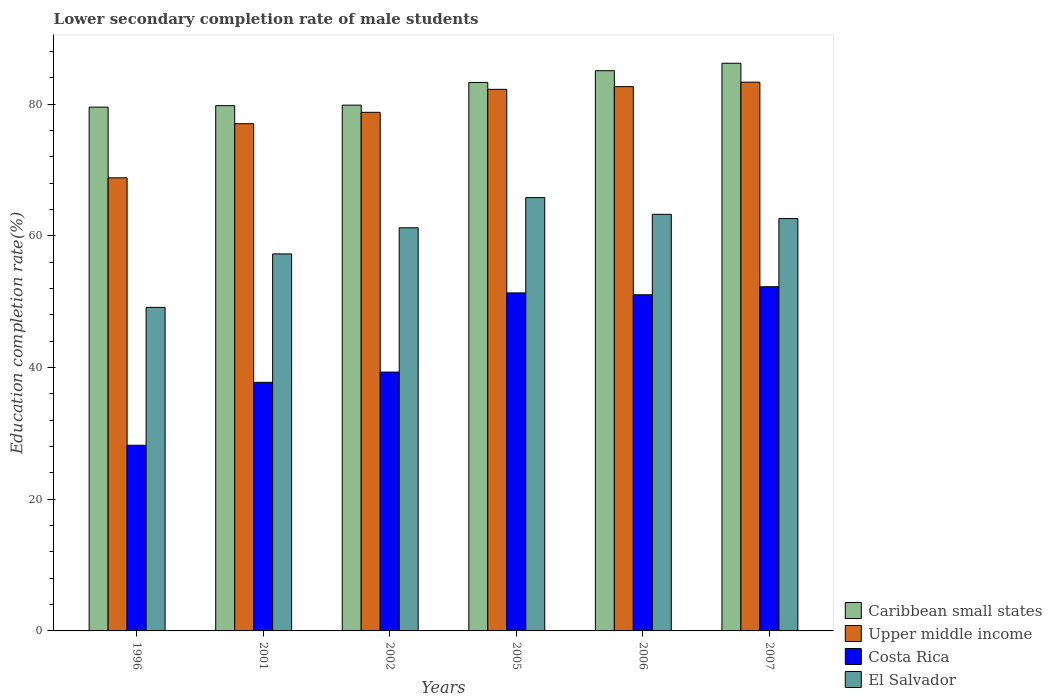How many different coloured bars are there?
Ensure brevity in your answer.  4. What is the label of the 3rd group of bars from the left?
Make the answer very short. 2002. In how many cases, is the number of bars for a given year not equal to the number of legend labels?
Make the answer very short. 0. What is the lower secondary completion rate of male students in Caribbean small states in 2006?
Provide a succinct answer. 85.1. Across all years, what is the maximum lower secondary completion rate of male students in Caribbean small states?
Make the answer very short. 86.23. Across all years, what is the minimum lower secondary completion rate of male students in Costa Rica?
Your answer should be very brief. 28.2. What is the total lower secondary completion rate of male students in Costa Rica in the graph?
Make the answer very short. 259.99. What is the difference between the lower secondary completion rate of male students in Upper middle income in 2005 and that in 2006?
Provide a succinct answer. -0.41. What is the difference between the lower secondary completion rate of male students in Upper middle income in 2005 and the lower secondary completion rate of male students in Costa Rica in 2006?
Your response must be concise. 31.2. What is the average lower secondary completion rate of male students in El Salvador per year?
Keep it short and to the point. 59.9. In the year 1996, what is the difference between the lower secondary completion rate of male students in Costa Rica and lower secondary completion rate of male students in Upper middle income?
Keep it short and to the point. -40.63. In how many years, is the lower secondary completion rate of male students in Costa Rica greater than 40 %?
Keep it short and to the point. 3. What is the ratio of the lower secondary completion rate of male students in Caribbean small states in 2001 to that in 2007?
Your answer should be very brief. 0.93. What is the difference between the highest and the second highest lower secondary completion rate of male students in Caribbean small states?
Provide a succinct answer. 1.13. What is the difference between the highest and the lowest lower secondary completion rate of male students in Upper middle income?
Provide a succinct answer. 14.53. Is the sum of the lower secondary completion rate of male students in Caribbean small states in 2002 and 2005 greater than the maximum lower secondary completion rate of male students in Upper middle income across all years?
Give a very brief answer. Yes. What does the 1st bar from the left in 2002 represents?
Provide a succinct answer. Caribbean small states. What does the 3rd bar from the right in 2007 represents?
Provide a short and direct response. Upper middle income. Is it the case that in every year, the sum of the lower secondary completion rate of male students in Upper middle income and lower secondary completion rate of male students in Costa Rica is greater than the lower secondary completion rate of male students in Caribbean small states?
Offer a terse response. Yes. Are all the bars in the graph horizontal?
Your response must be concise. No. What is the difference between two consecutive major ticks on the Y-axis?
Offer a terse response. 20. Are the values on the major ticks of Y-axis written in scientific E-notation?
Offer a very short reply. No. Does the graph contain any zero values?
Offer a terse response. No. Does the graph contain grids?
Your answer should be compact. No. Where does the legend appear in the graph?
Provide a succinct answer. Bottom right. What is the title of the graph?
Provide a succinct answer. Lower secondary completion rate of male students. Does "Chad" appear as one of the legend labels in the graph?
Provide a short and direct response. No. What is the label or title of the X-axis?
Give a very brief answer. Years. What is the label or title of the Y-axis?
Your answer should be very brief. Education completion rate(%). What is the Education completion rate(%) in Caribbean small states in 1996?
Keep it short and to the point. 79.57. What is the Education completion rate(%) of Upper middle income in 1996?
Your answer should be very brief. 68.83. What is the Education completion rate(%) in Costa Rica in 1996?
Your answer should be very brief. 28.2. What is the Education completion rate(%) in El Salvador in 1996?
Offer a very short reply. 49.15. What is the Education completion rate(%) of Caribbean small states in 2001?
Your response must be concise. 79.79. What is the Education completion rate(%) of Upper middle income in 2001?
Make the answer very short. 77.05. What is the Education completion rate(%) in Costa Rica in 2001?
Provide a short and direct response. 37.76. What is the Education completion rate(%) in El Salvador in 2001?
Your answer should be compact. 57.27. What is the Education completion rate(%) in Caribbean small states in 2002?
Offer a very short reply. 79.87. What is the Education completion rate(%) of Upper middle income in 2002?
Your response must be concise. 78.78. What is the Education completion rate(%) of Costa Rica in 2002?
Offer a very short reply. 39.32. What is the Education completion rate(%) of El Salvador in 2002?
Make the answer very short. 61.24. What is the Education completion rate(%) of Caribbean small states in 2005?
Give a very brief answer. 83.32. What is the Education completion rate(%) in Upper middle income in 2005?
Offer a terse response. 82.27. What is the Education completion rate(%) of Costa Rica in 2005?
Offer a terse response. 51.35. What is the Education completion rate(%) in El Salvador in 2005?
Give a very brief answer. 65.83. What is the Education completion rate(%) of Caribbean small states in 2006?
Your answer should be very brief. 85.1. What is the Education completion rate(%) in Upper middle income in 2006?
Make the answer very short. 82.68. What is the Education completion rate(%) in Costa Rica in 2006?
Your answer should be compact. 51.07. What is the Education completion rate(%) in El Salvador in 2006?
Ensure brevity in your answer.  63.29. What is the Education completion rate(%) of Caribbean small states in 2007?
Offer a very short reply. 86.23. What is the Education completion rate(%) in Upper middle income in 2007?
Your answer should be compact. 83.36. What is the Education completion rate(%) in Costa Rica in 2007?
Keep it short and to the point. 52.29. What is the Education completion rate(%) of El Salvador in 2007?
Provide a short and direct response. 62.64. Across all years, what is the maximum Education completion rate(%) in Caribbean small states?
Provide a short and direct response. 86.23. Across all years, what is the maximum Education completion rate(%) in Upper middle income?
Ensure brevity in your answer.  83.36. Across all years, what is the maximum Education completion rate(%) of Costa Rica?
Your answer should be very brief. 52.29. Across all years, what is the maximum Education completion rate(%) in El Salvador?
Ensure brevity in your answer.  65.83. Across all years, what is the minimum Education completion rate(%) of Caribbean small states?
Your response must be concise. 79.57. Across all years, what is the minimum Education completion rate(%) of Upper middle income?
Your response must be concise. 68.83. Across all years, what is the minimum Education completion rate(%) in Costa Rica?
Your response must be concise. 28.2. Across all years, what is the minimum Education completion rate(%) of El Salvador?
Make the answer very short. 49.15. What is the total Education completion rate(%) of Caribbean small states in the graph?
Provide a short and direct response. 493.88. What is the total Education completion rate(%) in Upper middle income in the graph?
Provide a short and direct response. 472.97. What is the total Education completion rate(%) in Costa Rica in the graph?
Your answer should be very brief. 259.99. What is the total Education completion rate(%) in El Salvador in the graph?
Your answer should be compact. 359.41. What is the difference between the Education completion rate(%) of Caribbean small states in 1996 and that in 2001?
Provide a succinct answer. -0.22. What is the difference between the Education completion rate(%) of Upper middle income in 1996 and that in 2001?
Make the answer very short. -8.22. What is the difference between the Education completion rate(%) in Costa Rica in 1996 and that in 2001?
Offer a terse response. -9.56. What is the difference between the Education completion rate(%) of El Salvador in 1996 and that in 2001?
Give a very brief answer. -8.12. What is the difference between the Education completion rate(%) of Caribbean small states in 1996 and that in 2002?
Make the answer very short. -0.3. What is the difference between the Education completion rate(%) in Upper middle income in 1996 and that in 2002?
Provide a succinct answer. -9.95. What is the difference between the Education completion rate(%) of Costa Rica in 1996 and that in 2002?
Your answer should be compact. -11.12. What is the difference between the Education completion rate(%) of El Salvador in 1996 and that in 2002?
Keep it short and to the point. -12.09. What is the difference between the Education completion rate(%) in Caribbean small states in 1996 and that in 2005?
Your answer should be very brief. -3.75. What is the difference between the Education completion rate(%) of Upper middle income in 1996 and that in 2005?
Offer a terse response. -13.44. What is the difference between the Education completion rate(%) in Costa Rica in 1996 and that in 2005?
Offer a very short reply. -23.14. What is the difference between the Education completion rate(%) in El Salvador in 1996 and that in 2005?
Offer a very short reply. -16.68. What is the difference between the Education completion rate(%) in Caribbean small states in 1996 and that in 2006?
Give a very brief answer. -5.53. What is the difference between the Education completion rate(%) in Upper middle income in 1996 and that in 2006?
Your answer should be compact. -13.85. What is the difference between the Education completion rate(%) of Costa Rica in 1996 and that in 2006?
Offer a very short reply. -22.86. What is the difference between the Education completion rate(%) in El Salvador in 1996 and that in 2006?
Your answer should be very brief. -14.14. What is the difference between the Education completion rate(%) in Caribbean small states in 1996 and that in 2007?
Your answer should be compact. -6.66. What is the difference between the Education completion rate(%) in Upper middle income in 1996 and that in 2007?
Your answer should be very brief. -14.53. What is the difference between the Education completion rate(%) of Costa Rica in 1996 and that in 2007?
Offer a terse response. -24.08. What is the difference between the Education completion rate(%) in El Salvador in 1996 and that in 2007?
Ensure brevity in your answer.  -13.49. What is the difference between the Education completion rate(%) of Caribbean small states in 2001 and that in 2002?
Offer a very short reply. -0.08. What is the difference between the Education completion rate(%) of Upper middle income in 2001 and that in 2002?
Your answer should be very brief. -1.73. What is the difference between the Education completion rate(%) in Costa Rica in 2001 and that in 2002?
Make the answer very short. -1.56. What is the difference between the Education completion rate(%) in El Salvador in 2001 and that in 2002?
Your answer should be very brief. -3.97. What is the difference between the Education completion rate(%) in Caribbean small states in 2001 and that in 2005?
Give a very brief answer. -3.52. What is the difference between the Education completion rate(%) of Upper middle income in 2001 and that in 2005?
Keep it short and to the point. -5.22. What is the difference between the Education completion rate(%) in Costa Rica in 2001 and that in 2005?
Ensure brevity in your answer.  -13.59. What is the difference between the Education completion rate(%) of El Salvador in 2001 and that in 2005?
Your answer should be compact. -8.56. What is the difference between the Education completion rate(%) of Caribbean small states in 2001 and that in 2006?
Keep it short and to the point. -5.31. What is the difference between the Education completion rate(%) of Upper middle income in 2001 and that in 2006?
Your response must be concise. -5.63. What is the difference between the Education completion rate(%) of Costa Rica in 2001 and that in 2006?
Offer a terse response. -13.3. What is the difference between the Education completion rate(%) of El Salvador in 2001 and that in 2006?
Make the answer very short. -6.02. What is the difference between the Education completion rate(%) in Caribbean small states in 2001 and that in 2007?
Offer a very short reply. -6.44. What is the difference between the Education completion rate(%) of Upper middle income in 2001 and that in 2007?
Offer a very short reply. -6.31. What is the difference between the Education completion rate(%) in Costa Rica in 2001 and that in 2007?
Provide a short and direct response. -14.53. What is the difference between the Education completion rate(%) in El Salvador in 2001 and that in 2007?
Your response must be concise. -5.37. What is the difference between the Education completion rate(%) of Caribbean small states in 2002 and that in 2005?
Your answer should be compact. -3.44. What is the difference between the Education completion rate(%) of Upper middle income in 2002 and that in 2005?
Provide a succinct answer. -3.49. What is the difference between the Education completion rate(%) in Costa Rica in 2002 and that in 2005?
Your response must be concise. -12.03. What is the difference between the Education completion rate(%) of El Salvador in 2002 and that in 2005?
Ensure brevity in your answer.  -4.59. What is the difference between the Education completion rate(%) in Caribbean small states in 2002 and that in 2006?
Offer a very short reply. -5.23. What is the difference between the Education completion rate(%) in Upper middle income in 2002 and that in 2006?
Provide a short and direct response. -3.9. What is the difference between the Education completion rate(%) of Costa Rica in 2002 and that in 2006?
Your answer should be very brief. -11.75. What is the difference between the Education completion rate(%) in El Salvador in 2002 and that in 2006?
Offer a very short reply. -2.05. What is the difference between the Education completion rate(%) in Caribbean small states in 2002 and that in 2007?
Keep it short and to the point. -6.36. What is the difference between the Education completion rate(%) of Upper middle income in 2002 and that in 2007?
Give a very brief answer. -4.58. What is the difference between the Education completion rate(%) in Costa Rica in 2002 and that in 2007?
Offer a very short reply. -12.97. What is the difference between the Education completion rate(%) in El Salvador in 2002 and that in 2007?
Your answer should be compact. -1.4. What is the difference between the Education completion rate(%) in Caribbean small states in 2005 and that in 2006?
Your answer should be very brief. -1.79. What is the difference between the Education completion rate(%) in Upper middle income in 2005 and that in 2006?
Provide a short and direct response. -0.41. What is the difference between the Education completion rate(%) of Costa Rica in 2005 and that in 2006?
Give a very brief answer. 0.28. What is the difference between the Education completion rate(%) of El Salvador in 2005 and that in 2006?
Provide a succinct answer. 2.54. What is the difference between the Education completion rate(%) in Caribbean small states in 2005 and that in 2007?
Your answer should be very brief. -2.92. What is the difference between the Education completion rate(%) in Upper middle income in 2005 and that in 2007?
Make the answer very short. -1.09. What is the difference between the Education completion rate(%) in Costa Rica in 2005 and that in 2007?
Provide a succinct answer. -0.94. What is the difference between the Education completion rate(%) in El Salvador in 2005 and that in 2007?
Offer a very short reply. 3.19. What is the difference between the Education completion rate(%) of Caribbean small states in 2006 and that in 2007?
Make the answer very short. -1.13. What is the difference between the Education completion rate(%) of Upper middle income in 2006 and that in 2007?
Provide a succinct answer. -0.68. What is the difference between the Education completion rate(%) of Costa Rica in 2006 and that in 2007?
Your answer should be compact. -1.22. What is the difference between the Education completion rate(%) of El Salvador in 2006 and that in 2007?
Your answer should be compact. 0.65. What is the difference between the Education completion rate(%) of Caribbean small states in 1996 and the Education completion rate(%) of Upper middle income in 2001?
Keep it short and to the point. 2.52. What is the difference between the Education completion rate(%) of Caribbean small states in 1996 and the Education completion rate(%) of Costa Rica in 2001?
Ensure brevity in your answer.  41.81. What is the difference between the Education completion rate(%) of Caribbean small states in 1996 and the Education completion rate(%) of El Salvador in 2001?
Offer a very short reply. 22.3. What is the difference between the Education completion rate(%) of Upper middle income in 1996 and the Education completion rate(%) of Costa Rica in 2001?
Your response must be concise. 31.07. What is the difference between the Education completion rate(%) in Upper middle income in 1996 and the Education completion rate(%) in El Salvador in 2001?
Ensure brevity in your answer.  11.56. What is the difference between the Education completion rate(%) of Costa Rica in 1996 and the Education completion rate(%) of El Salvador in 2001?
Make the answer very short. -29.07. What is the difference between the Education completion rate(%) of Caribbean small states in 1996 and the Education completion rate(%) of Upper middle income in 2002?
Offer a terse response. 0.79. What is the difference between the Education completion rate(%) in Caribbean small states in 1996 and the Education completion rate(%) in Costa Rica in 2002?
Ensure brevity in your answer.  40.25. What is the difference between the Education completion rate(%) in Caribbean small states in 1996 and the Education completion rate(%) in El Salvador in 2002?
Offer a very short reply. 18.33. What is the difference between the Education completion rate(%) of Upper middle income in 1996 and the Education completion rate(%) of Costa Rica in 2002?
Make the answer very short. 29.51. What is the difference between the Education completion rate(%) of Upper middle income in 1996 and the Education completion rate(%) of El Salvador in 2002?
Make the answer very short. 7.59. What is the difference between the Education completion rate(%) in Costa Rica in 1996 and the Education completion rate(%) in El Salvador in 2002?
Offer a terse response. -33.04. What is the difference between the Education completion rate(%) in Caribbean small states in 1996 and the Education completion rate(%) in Upper middle income in 2005?
Keep it short and to the point. -2.7. What is the difference between the Education completion rate(%) in Caribbean small states in 1996 and the Education completion rate(%) in Costa Rica in 2005?
Your response must be concise. 28.22. What is the difference between the Education completion rate(%) of Caribbean small states in 1996 and the Education completion rate(%) of El Salvador in 2005?
Give a very brief answer. 13.74. What is the difference between the Education completion rate(%) of Upper middle income in 1996 and the Education completion rate(%) of Costa Rica in 2005?
Your answer should be compact. 17.48. What is the difference between the Education completion rate(%) in Upper middle income in 1996 and the Education completion rate(%) in El Salvador in 2005?
Your response must be concise. 3. What is the difference between the Education completion rate(%) of Costa Rica in 1996 and the Education completion rate(%) of El Salvador in 2005?
Keep it short and to the point. -37.63. What is the difference between the Education completion rate(%) in Caribbean small states in 1996 and the Education completion rate(%) in Upper middle income in 2006?
Your response must be concise. -3.11. What is the difference between the Education completion rate(%) of Caribbean small states in 1996 and the Education completion rate(%) of Costa Rica in 2006?
Your answer should be compact. 28.5. What is the difference between the Education completion rate(%) of Caribbean small states in 1996 and the Education completion rate(%) of El Salvador in 2006?
Your answer should be very brief. 16.28. What is the difference between the Education completion rate(%) of Upper middle income in 1996 and the Education completion rate(%) of Costa Rica in 2006?
Provide a short and direct response. 17.76. What is the difference between the Education completion rate(%) of Upper middle income in 1996 and the Education completion rate(%) of El Salvador in 2006?
Give a very brief answer. 5.54. What is the difference between the Education completion rate(%) of Costa Rica in 1996 and the Education completion rate(%) of El Salvador in 2006?
Your answer should be compact. -35.08. What is the difference between the Education completion rate(%) of Caribbean small states in 1996 and the Education completion rate(%) of Upper middle income in 2007?
Offer a terse response. -3.79. What is the difference between the Education completion rate(%) of Caribbean small states in 1996 and the Education completion rate(%) of Costa Rica in 2007?
Offer a very short reply. 27.28. What is the difference between the Education completion rate(%) in Caribbean small states in 1996 and the Education completion rate(%) in El Salvador in 2007?
Give a very brief answer. 16.93. What is the difference between the Education completion rate(%) of Upper middle income in 1996 and the Education completion rate(%) of Costa Rica in 2007?
Your response must be concise. 16.54. What is the difference between the Education completion rate(%) of Upper middle income in 1996 and the Education completion rate(%) of El Salvador in 2007?
Provide a short and direct response. 6.19. What is the difference between the Education completion rate(%) in Costa Rica in 1996 and the Education completion rate(%) in El Salvador in 2007?
Provide a short and direct response. -34.44. What is the difference between the Education completion rate(%) of Caribbean small states in 2001 and the Education completion rate(%) of Upper middle income in 2002?
Your answer should be compact. 1.01. What is the difference between the Education completion rate(%) of Caribbean small states in 2001 and the Education completion rate(%) of Costa Rica in 2002?
Ensure brevity in your answer.  40.47. What is the difference between the Education completion rate(%) of Caribbean small states in 2001 and the Education completion rate(%) of El Salvador in 2002?
Make the answer very short. 18.55. What is the difference between the Education completion rate(%) in Upper middle income in 2001 and the Education completion rate(%) in Costa Rica in 2002?
Your answer should be compact. 37.73. What is the difference between the Education completion rate(%) of Upper middle income in 2001 and the Education completion rate(%) of El Salvador in 2002?
Make the answer very short. 15.81. What is the difference between the Education completion rate(%) of Costa Rica in 2001 and the Education completion rate(%) of El Salvador in 2002?
Your answer should be compact. -23.48. What is the difference between the Education completion rate(%) in Caribbean small states in 2001 and the Education completion rate(%) in Upper middle income in 2005?
Keep it short and to the point. -2.48. What is the difference between the Education completion rate(%) in Caribbean small states in 2001 and the Education completion rate(%) in Costa Rica in 2005?
Give a very brief answer. 28.45. What is the difference between the Education completion rate(%) of Caribbean small states in 2001 and the Education completion rate(%) of El Salvador in 2005?
Provide a succinct answer. 13.97. What is the difference between the Education completion rate(%) in Upper middle income in 2001 and the Education completion rate(%) in Costa Rica in 2005?
Keep it short and to the point. 25.7. What is the difference between the Education completion rate(%) of Upper middle income in 2001 and the Education completion rate(%) of El Salvador in 2005?
Your answer should be very brief. 11.22. What is the difference between the Education completion rate(%) in Costa Rica in 2001 and the Education completion rate(%) in El Salvador in 2005?
Your answer should be compact. -28.07. What is the difference between the Education completion rate(%) of Caribbean small states in 2001 and the Education completion rate(%) of Upper middle income in 2006?
Make the answer very short. -2.89. What is the difference between the Education completion rate(%) in Caribbean small states in 2001 and the Education completion rate(%) in Costa Rica in 2006?
Provide a succinct answer. 28.73. What is the difference between the Education completion rate(%) of Caribbean small states in 2001 and the Education completion rate(%) of El Salvador in 2006?
Make the answer very short. 16.51. What is the difference between the Education completion rate(%) in Upper middle income in 2001 and the Education completion rate(%) in Costa Rica in 2006?
Offer a terse response. 25.98. What is the difference between the Education completion rate(%) in Upper middle income in 2001 and the Education completion rate(%) in El Salvador in 2006?
Make the answer very short. 13.77. What is the difference between the Education completion rate(%) in Costa Rica in 2001 and the Education completion rate(%) in El Salvador in 2006?
Provide a succinct answer. -25.52. What is the difference between the Education completion rate(%) of Caribbean small states in 2001 and the Education completion rate(%) of Upper middle income in 2007?
Offer a terse response. -3.56. What is the difference between the Education completion rate(%) of Caribbean small states in 2001 and the Education completion rate(%) of Costa Rica in 2007?
Your response must be concise. 27.51. What is the difference between the Education completion rate(%) in Caribbean small states in 2001 and the Education completion rate(%) in El Salvador in 2007?
Offer a terse response. 17.15. What is the difference between the Education completion rate(%) in Upper middle income in 2001 and the Education completion rate(%) in Costa Rica in 2007?
Your response must be concise. 24.76. What is the difference between the Education completion rate(%) in Upper middle income in 2001 and the Education completion rate(%) in El Salvador in 2007?
Provide a succinct answer. 14.41. What is the difference between the Education completion rate(%) of Costa Rica in 2001 and the Education completion rate(%) of El Salvador in 2007?
Keep it short and to the point. -24.88. What is the difference between the Education completion rate(%) in Caribbean small states in 2002 and the Education completion rate(%) in Upper middle income in 2005?
Offer a very short reply. -2.4. What is the difference between the Education completion rate(%) in Caribbean small states in 2002 and the Education completion rate(%) in Costa Rica in 2005?
Offer a terse response. 28.52. What is the difference between the Education completion rate(%) in Caribbean small states in 2002 and the Education completion rate(%) in El Salvador in 2005?
Your answer should be very brief. 14.04. What is the difference between the Education completion rate(%) in Upper middle income in 2002 and the Education completion rate(%) in Costa Rica in 2005?
Keep it short and to the point. 27.43. What is the difference between the Education completion rate(%) of Upper middle income in 2002 and the Education completion rate(%) of El Salvador in 2005?
Offer a very short reply. 12.95. What is the difference between the Education completion rate(%) in Costa Rica in 2002 and the Education completion rate(%) in El Salvador in 2005?
Your answer should be very brief. -26.51. What is the difference between the Education completion rate(%) in Caribbean small states in 2002 and the Education completion rate(%) in Upper middle income in 2006?
Your answer should be compact. -2.81. What is the difference between the Education completion rate(%) of Caribbean small states in 2002 and the Education completion rate(%) of Costa Rica in 2006?
Offer a very short reply. 28.81. What is the difference between the Education completion rate(%) in Caribbean small states in 2002 and the Education completion rate(%) in El Salvador in 2006?
Your answer should be compact. 16.59. What is the difference between the Education completion rate(%) in Upper middle income in 2002 and the Education completion rate(%) in Costa Rica in 2006?
Your answer should be very brief. 27.71. What is the difference between the Education completion rate(%) of Upper middle income in 2002 and the Education completion rate(%) of El Salvador in 2006?
Provide a succinct answer. 15.5. What is the difference between the Education completion rate(%) in Costa Rica in 2002 and the Education completion rate(%) in El Salvador in 2006?
Ensure brevity in your answer.  -23.97. What is the difference between the Education completion rate(%) of Caribbean small states in 2002 and the Education completion rate(%) of Upper middle income in 2007?
Offer a terse response. -3.49. What is the difference between the Education completion rate(%) of Caribbean small states in 2002 and the Education completion rate(%) of Costa Rica in 2007?
Your answer should be compact. 27.58. What is the difference between the Education completion rate(%) in Caribbean small states in 2002 and the Education completion rate(%) in El Salvador in 2007?
Make the answer very short. 17.23. What is the difference between the Education completion rate(%) in Upper middle income in 2002 and the Education completion rate(%) in Costa Rica in 2007?
Give a very brief answer. 26.49. What is the difference between the Education completion rate(%) of Upper middle income in 2002 and the Education completion rate(%) of El Salvador in 2007?
Make the answer very short. 16.14. What is the difference between the Education completion rate(%) in Costa Rica in 2002 and the Education completion rate(%) in El Salvador in 2007?
Make the answer very short. -23.32. What is the difference between the Education completion rate(%) in Caribbean small states in 2005 and the Education completion rate(%) in Upper middle income in 2006?
Provide a succinct answer. 0.63. What is the difference between the Education completion rate(%) in Caribbean small states in 2005 and the Education completion rate(%) in Costa Rica in 2006?
Your response must be concise. 32.25. What is the difference between the Education completion rate(%) of Caribbean small states in 2005 and the Education completion rate(%) of El Salvador in 2006?
Provide a short and direct response. 20.03. What is the difference between the Education completion rate(%) in Upper middle income in 2005 and the Education completion rate(%) in Costa Rica in 2006?
Provide a short and direct response. 31.2. What is the difference between the Education completion rate(%) in Upper middle income in 2005 and the Education completion rate(%) in El Salvador in 2006?
Make the answer very short. 18.99. What is the difference between the Education completion rate(%) of Costa Rica in 2005 and the Education completion rate(%) of El Salvador in 2006?
Give a very brief answer. -11.94. What is the difference between the Education completion rate(%) of Caribbean small states in 2005 and the Education completion rate(%) of Upper middle income in 2007?
Ensure brevity in your answer.  -0.04. What is the difference between the Education completion rate(%) of Caribbean small states in 2005 and the Education completion rate(%) of Costa Rica in 2007?
Ensure brevity in your answer.  31.03. What is the difference between the Education completion rate(%) of Caribbean small states in 2005 and the Education completion rate(%) of El Salvador in 2007?
Provide a succinct answer. 20.68. What is the difference between the Education completion rate(%) of Upper middle income in 2005 and the Education completion rate(%) of Costa Rica in 2007?
Keep it short and to the point. 29.98. What is the difference between the Education completion rate(%) in Upper middle income in 2005 and the Education completion rate(%) in El Salvador in 2007?
Your response must be concise. 19.63. What is the difference between the Education completion rate(%) of Costa Rica in 2005 and the Education completion rate(%) of El Salvador in 2007?
Give a very brief answer. -11.29. What is the difference between the Education completion rate(%) of Caribbean small states in 2006 and the Education completion rate(%) of Upper middle income in 2007?
Provide a succinct answer. 1.74. What is the difference between the Education completion rate(%) in Caribbean small states in 2006 and the Education completion rate(%) in Costa Rica in 2007?
Your answer should be very brief. 32.81. What is the difference between the Education completion rate(%) in Caribbean small states in 2006 and the Education completion rate(%) in El Salvador in 2007?
Make the answer very short. 22.46. What is the difference between the Education completion rate(%) in Upper middle income in 2006 and the Education completion rate(%) in Costa Rica in 2007?
Make the answer very short. 30.39. What is the difference between the Education completion rate(%) of Upper middle income in 2006 and the Education completion rate(%) of El Salvador in 2007?
Keep it short and to the point. 20.04. What is the difference between the Education completion rate(%) of Costa Rica in 2006 and the Education completion rate(%) of El Salvador in 2007?
Offer a terse response. -11.57. What is the average Education completion rate(%) of Caribbean small states per year?
Offer a terse response. 82.31. What is the average Education completion rate(%) in Upper middle income per year?
Keep it short and to the point. 78.83. What is the average Education completion rate(%) in Costa Rica per year?
Provide a short and direct response. 43.33. What is the average Education completion rate(%) of El Salvador per year?
Your answer should be very brief. 59.9. In the year 1996, what is the difference between the Education completion rate(%) of Caribbean small states and Education completion rate(%) of Upper middle income?
Ensure brevity in your answer.  10.74. In the year 1996, what is the difference between the Education completion rate(%) of Caribbean small states and Education completion rate(%) of Costa Rica?
Keep it short and to the point. 51.37. In the year 1996, what is the difference between the Education completion rate(%) of Caribbean small states and Education completion rate(%) of El Salvador?
Give a very brief answer. 30.42. In the year 1996, what is the difference between the Education completion rate(%) of Upper middle income and Education completion rate(%) of Costa Rica?
Ensure brevity in your answer.  40.62. In the year 1996, what is the difference between the Education completion rate(%) in Upper middle income and Education completion rate(%) in El Salvador?
Provide a succinct answer. 19.68. In the year 1996, what is the difference between the Education completion rate(%) of Costa Rica and Education completion rate(%) of El Salvador?
Make the answer very short. -20.95. In the year 2001, what is the difference between the Education completion rate(%) of Caribbean small states and Education completion rate(%) of Upper middle income?
Provide a succinct answer. 2.74. In the year 2001, what is the difference between the Education completion rate(%) of Caribbean small states and Education completion rate(%) of Costa Rica?
Your answer should be very brief. 42.03. In the year 2001, what is the difference between the Education completion rate(%) of Caribbean small states and Education completion rate(%) of El Salvador?
Give a very brief answer. 22.53. In the year 2001, what is the difference between the Education completion rate(%) in Upper middle income and Education completion rate(%) in Costa Rica?
Offer a very short reply. 39.29. In the year 2001, what is the difference between the Education completion rate(%) in Upper middle income and Education completion rate(%) in El Salvador?
Offer a very short reply. 19.78. In the year 2001, what is the difference between the Education completion rate(%) in Costa Rica and Education completion rate(%) in El Salvador?
Offer a very short reply. -19.51. In the year 2002, what is the difference between the Education completion rate(%) in Caribbean small states and Education completion rate(%) in Upper middle income?
Ensure brevity in your answer.  1.09. In the year 2002, what is the difference between the Education completion rate(%) in Caribbean small states and Education completion rate(%) in Costa Rica?
Your response must be concise. 40.55. In the year 2002, what is the difference between the Education completion rate(%) in Caribbean small states and Education completion rate(%) in El Salvador?
Give a very brief answer. 18.63. In the year 2002, what is the difference between the Education completion rate(%) in Upper middle income and Education completion rate(%) in Costa Rica?
Make the answer very short. 39.46. In the year 2002, what is the difference between the Education completion rate(%) of Upper middle income and Education completion rate(%) of El Salvador?
Offer a terse response. 17.54. In the year 2002, what is the difference between the Education completion rate(%) in Costa Rica and Education completion rate(%) in El Salvador?
Provide a short and direct response. -21.92. In the year 2005, what is the difference between the Education completion rate(%) of Caribbean small states and Education completion rate(%) of Upper middle income?
Provide a short and direct response. 1.04. In the year 2005, what is the difference between the Education completion rate(%) in Caribbean small states and Education completion rate(%) in Costa Rica?
Ensure brevity in your answer.  31.97. In the year 2005, what is the difference between the Education completion rate(%) of Caribbean small states and Education completion rate(%) of El Salvador?
Make the answer very short. 17.49. In the year 2005, what is the difference between the Education completion rate(%) of Upper middle income and Education completion rate(%) of Costa Rica?
Ensure brevity in your answer.  30.92. In the year 2005, what is the difference between the Education completion rate(%) in Upper middle income and Education completion rate(%) in El Salvador?
Ensure brevity in your answer.  16.44. In the year 2005, what is the difference between the Education completion rate(%) of Costa Rica and Education completion rate(%) of El Salvador?
Ensure brevity in your answer.  -14.48. In the year 2006, what is the difference between the Education completion rate(%) of Caribbean small states and Education completion rate(%) of Upper middle income?
Provide a short and direct response. 2.42. In the year 2006, what is the difference between the Education completion rate(%) in Caribbean small states and Education completion rate(%) in Costa Rica?
Provide a succinct answer. 34.03. In the year 2006, what is the difference between the Education completion rate(%) in Caribbean small states and Education completion rate(%) in El Salvador?
Give a very brief answer. 21.82. In the year 2006, what is the difference between the Education completion rate(%) of Upper middle income and Education completion rate(%) of Costa Rica?
Give a very brief answer. 31.62. In the year 2006, what is the difference between the Education completion rate(%) of Upper middle income and Education completion rate(%) of El Salvador?
Your response must be concise. 19.4. In the year 2006, what is the difference between the Education completion rate(%) of Costa Rica and Education completion rate(%) of El Salvador?
Provide a short and direct response. -12.22. In the year 2007, what is the difference between the Education completion rate(%) of Caribbean small states and Education completion rate(%) of Upper middle income?
Make the answer very short. 2.87. In the year 2007, what is the difference between the Education completion rate(%) in Caribbean small states and Education completion rate(%) in Costa Rica?
Provide a succinct answer. 33.95. In the year 2007, what is the difference between the Education completion rate(%) of Caribbean small states and Education completion rate(%) of El Salvador?
Provide a short and direct response. 23.59. In the year 2007, what is the difference between the Education completion rate(%) of Upper middle income and Education completion rate(%) of Costa Rica?
Provide a succinct answer. 31.07. In the year 2007, what is the difference between the Education completion rate(%) in Upper middle income and Education completion rate(%) in El Salvador?
Provide a short and direct response. 20.72. In the year 2007, what is the difference between the Education completion rate(%) in Costa Rica and Education completion rate(%) in El Salvador?
Keep it short and to the point. -10.35. What is the ratio of the Education completion rate(%) of Upper middle income in 1996 to that in 2001?
Ensure brevity in your answer.  0.89. What is the ratio of the Education completion rate(%) of Costa Rica in 1996 to that in 2001?
Offer a terse response. 0.75. What is the ratio of the Education completion rate(%) in El Salvador in 1996 to that in 2001?
Provide a short and direct response. 0.86. What is the ratio of the Education completion rate(%) of Upper middle income in 1996 to that in 2002?
Offer a very short reply. 0.87. What is the ratio of the Education completion rate(%) in Costa Rica in 1996 to that in 2002?
Ensure brevity in your answer.  0.72. What is the ratio of the Education completion rate(%) of El Salvador in 1996 to that in 2002?
Offer a terse response. 0.8. What is the ratio of the Education completion rate(%) in Caribbean small states in 1996 to that in 2005?
Make the answer very short. 0.95. What is the ratio of the Education completion rate(%) of Upper middle income in 1996 to that in 2005?
Ensure brevity in your answer.  0.84. What is the ratio of the Education completion rate(%) of Costa Rica in 1996 to that in 2005?
Offer a very short reply. 0.55. What is the ratio of the Education completion rate(%) in El Salvador in 1996 to that in 2005?
Your answer should be very brief. 0.75. What is the ratio of the Education completion rate(%) of Caribbean small states in 1996 to that in 2006?
Make the answer very short. 0.94. What is the ratio of the Education completion rate(%) in Upper middle income in 1996 to that in 2006?
Ensure brevity in your answer.  0.83. What is the ratio of the Education completion rate(%) in Costa Rica in 1996 to that in 2006?
Offer a terse response. 0.55. What is the ratio of the Education completion rate(%) of El Salvador in 1996 to that in 2006?
Your answer should be very brief. 0.78. What is the ratio of the Education completion rate(%) in Caribbean small states in 1996 to that in 2007?
Your answer should be compact. 0.92. What is the ratio of the Education completion rate(%) of Upper middle income in 1996 to that in 2007?
Your answer should be compact. 0.83. What is the ratio of the Education completion rate(%) of Costa Rica in 1996 to that in 2007?
Provide a short and direct response. 0.54. What is the ratio of the Education completion rate(%) of El Salvador in 1996 to that in 2007?
Keep it short and to the point. 0.78. What is the ratio of the Education completion rate(%) in Caribbean small states in 2001 to that in 2002?
Provide a short and direct response. 1. What is the ratio of the Education completion rate(%) in Upper middle income in 2001 to that in 2002?
Ensure brevity in your answer.  0.98. What is the ratio of the Education completion rate(%) of Costa Rica in 2001 to that in 2002?
Keep it short and to the point. 0.96. What is the ratio of the Education completion rate(%) of El Salvador in 2001 to that in 2002?
Make the answer very short. 0.94. What is the ratio of the Education completion rate(%) in Caribbean small states in 2001 to that in 2005?
Provide a short and direct response. 0.96. What is the ratio of the Education completion rate(%) of Upper middle income in 2001 to that in 2005?
Give a very brief answer. 0.94. What is the ratio of the Education completion rate(%) in Costa Rica in 2001 to that in 2005?
Make the answer very short. 0.74. What is the ratio of the Education completion rate(%) of El Salvador in 2001 to that in 2005?
Keep it short and to the point. 0.87. What is the ratio of the Education completion rate(%) of Caribbean small states in 2001 to that in 2006?
Your answer should be compact. 0.94. What is the ratio of the Education completion rate(%) of Upper middle income in 2001 to that in 2006?
Your answer should be compact. 0.93. What is the ratio of the Education completion rate(%) of Costa Rica in 2001 to that in 2006?
Offer a terse response. 0.74. What is the ratio of the Education completion rate(%) of El Salvador in 2001 to that in 2006?
Keep it short and to the point. 0.9. What is the ratio of the Education completion rate(%) of Caribbean small states in 2001 to that in 2007?
Your answer should be compact. 0.93. What is the ratio of the Education completion rate(%) in Upper middle income in 2001 to that in 2007?
Your answer should be very brief. 0.92. What is the ratio of the Education completion rate(%) of Costa Rica in 2001 to that in 2007?
Offer a terse response. 0.72. What is the ratio of the Education completion rate(%) in El Salvador in 2001 to that in 2007?
Offer a very short reply. 0.91. What is the ratio of the Education completion rate(%) in Caribbean small states in 2002 to that in 2005?
Your response must be concise. 0.96. What is the ratio of the Education completion rate(%) in Upper middle income in 2002 to that in 2005?
Your answer should be compact. 0.96. What is the ratio of the Education completion rate(%) in Costa Rica in 2002 to that in 2005?
Offer a very short reply. 0.77. What is the ratio of the Education completion rate(%) of El Salvador in 2002 to that in 2005?
Offer a terse response. 0.93. What is the ratio of the Education completion rate(%) in Caribbean small states in 2002 to that in 2006?
Your response must be concise. 0.94. What is the ratio of the Education completion rate(%) of Upper middle income in 2002 to that in 2006?
Your response must be concise. 0.95. What is the ratio of the Education completion rate(%) in Costa Rica in 2002 to that in 2006?
Your answer should be compact. 0.77. What is the ratio of the Education completion rate(%) in Caribbean small states in 2002 to that in 2007?
Provide a short and direct response. 0.93. What is the ratio of the Education completion rate(%) of Upper middle income in 2002 to that in 2007?
Provide a short and direct response. 0.95. What is the ratio of the Education completion rate(%) in Costa Rica in 2002 to that in 2007?
Make the answer very short. 0.75. What is the ratio of the Education completion rate(%) in El Salvador in 2002 to that in 2007?
Offer a very short reply. 0.98. What is the ratio of the Education completion rate(%) of Upper middle income in 2005 to that in 2006?
Give a very brief answer. 0.99. What is the ratio of the Education completion rate(%) of El Salvador in 2005 to that in 2006?
Give a very brief answer. 1.04. What is the ratio of the Education completion rate(%) in Caribbean small states in 2005 to that in 2007?
Provide a succinct answer. 0.97. What is the ratio of the Education completion rate(%) of Costa Rica in 2005 to that in 2007?
Ensure brevity in your answer.  0.98. What is the ratio of the Education completion rate(%) in El Salvador in 2005 to that in 2007?
Ensure brevity in your answer.  1.05. What is the ratio of the Education completion rate(%) of Caribbean small states in 2006 to that in 2007?
Provide a succinct answer. 0.99. What is the ratio of the Education completion rate(%) in Costa Rica in 2006 to that in 2007?
Give a very brief answer. 0.98. What is the ratio of the Education completion rate(%) of El Salvador in 2006 to that in 2007?
Give a very brief answer. 1.01. What is the difference between the highest and the second highest Education completion rate(%) of Caribbean small states?
Give a very brief answer. 1.13. What is the difference between the highest and the second highest Education completion rate(%) of Upper middle income?
Make the answer very short. 0.68. What is the difference between the highest and the second highest Education completion rate(%) in Costa Rica?
Ensure brevity in your answer.  0.94. What is the difference between the highest and the second highest Education completion rate(%) in El Salvador?
Provide a succinct answer. 2.54. What is the difference between the highest and the lowest Education completion rate(%) of Caribbean small states?
Keep it short and to the point. 6.66. What is the difference between the highest and the lowest Education completion rate(%) in Upper middle income?
Make the answer very short. 14.53. What is the difference between the highest and the lowest Education completion rate(%) of Costa Rica?
Offer a terse response. 24.08. What is the difference between the highest and the lowest Education completion rate(%) in El Salvador?
Your answer should be very brief. 16.68. 